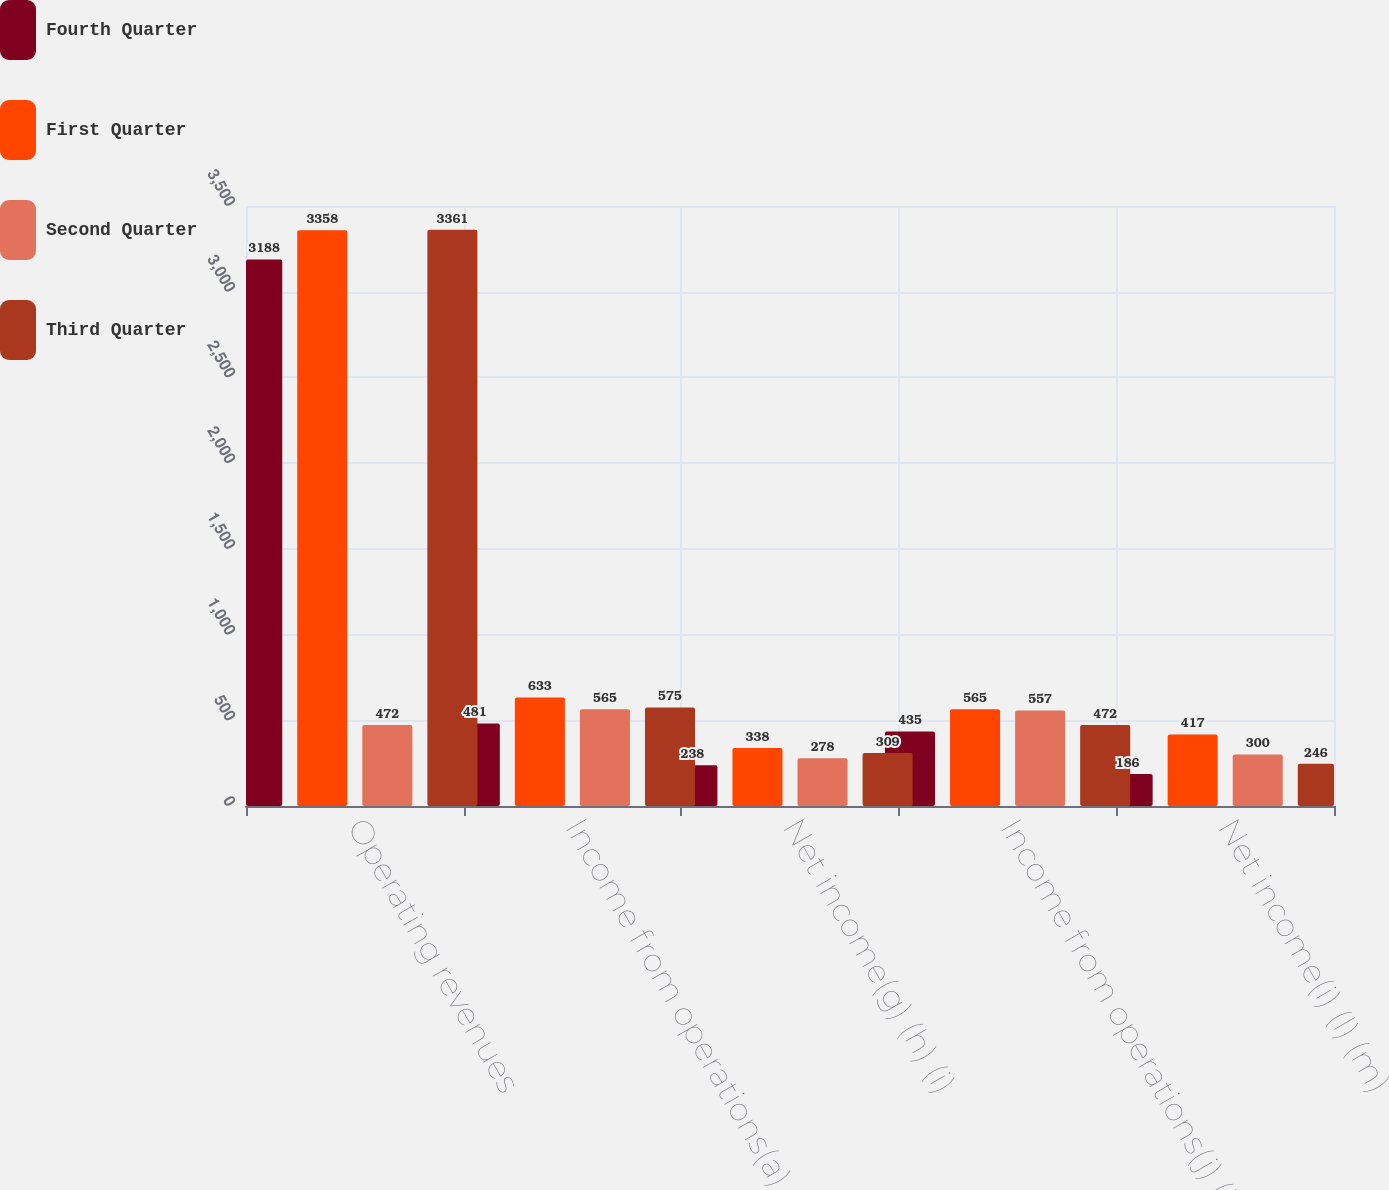Convert chart to OTSL. <chart><loc_0><loc_0><loc_500><loc_500><stacked_bar_chart><ecel><fcel>Operating revenues<fcel>Income from operations(a) (b)<fcel>Net income(g) (h) (i)<fcel>Income from operations(j) (k)<fcel>Net income(i) (l) (m)<nl><fcel>Fourth Quarter<fcel>3188<fcel>481<fcel>238<fcel>435<fcel>186<nl><fcel>First Quarter<fcel>3358<fcel>633<fcel>338<fcel>565<fcel>417<nl><fcel>Second Quarter<fcel>472<fcel>565<fcel>278<fcel>557<fcel>300<nl><fcel>Third Quarter<fcel>3361<fcel>575<fcel>309<fcel>472<fcel>246<nl></chart> 